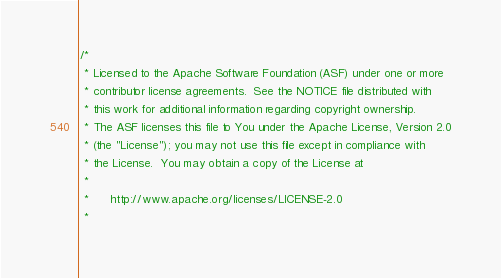<code> <loc_0><loc_0><loc_500><loc_500><_Scala_>/*
 * Licensed to the Apache Software Foundation (ASF) under one or more
 * contributor license agreements.  See the NOTICE file distributed with
 * this work for additional information regarding copyright ownership.
 * The ASF licenses this file to You under the Apache License, Version 2.0
 * (the "License"); you may not use this file except in compliance with
 * the License.  You may obtain a copy of the License at
 *
 *      http://www.apache.org/licenses/LICENSE-2.0
 *</code> 